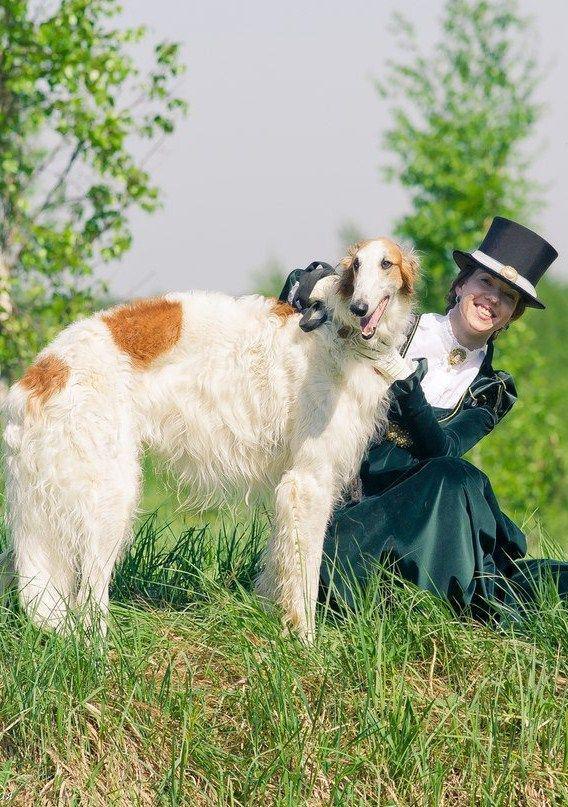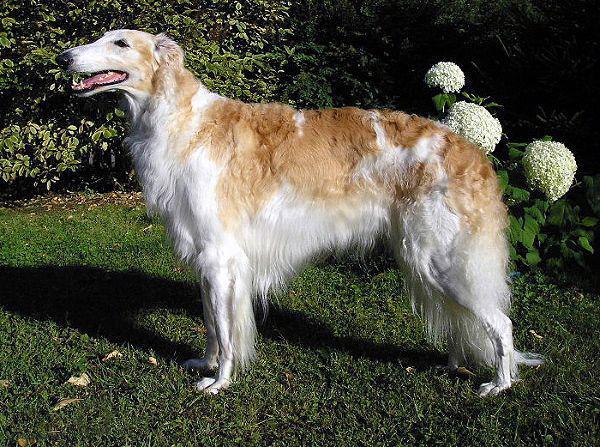The first image is the image on the left, the second image is the image on the right. Analyze the images presented: Is the assertion "A person is upright near a hound in one image." valid? Answer yes or no. No. The first image is the image on the left, the second image is the image on the right. For the images displayed, is the sentence "there is exactly one person in the image on the right." factually correct? Answer yes or no. No. 